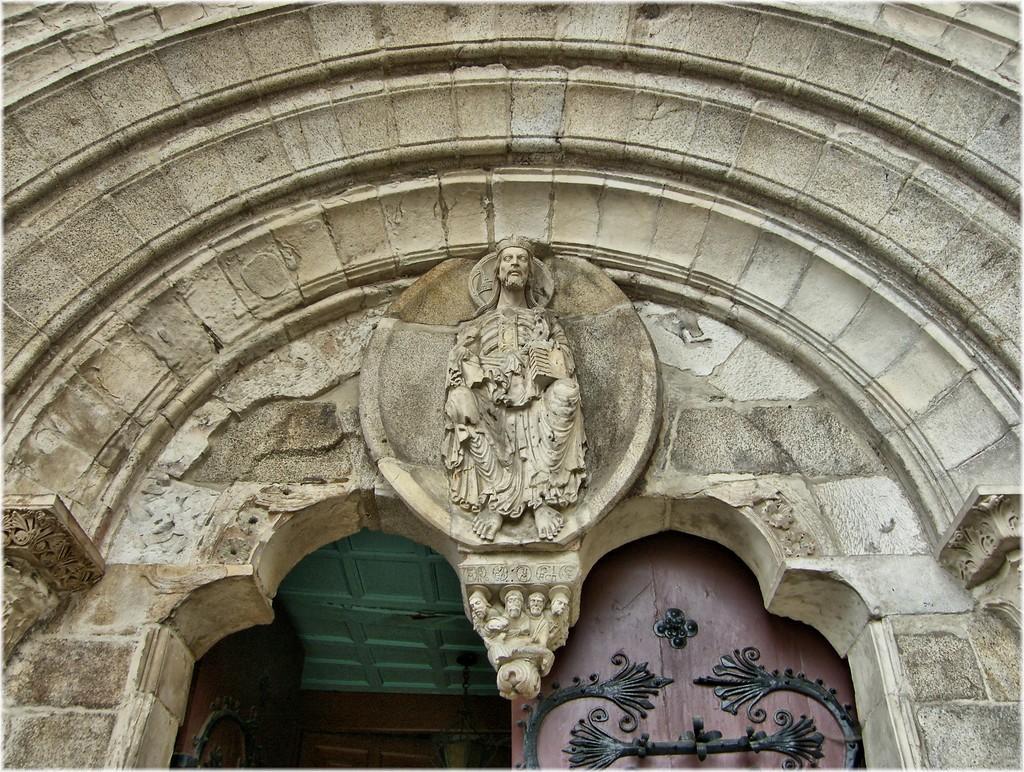Describe this image in one or two sentences. In this image we can see the top of the building. There is an architecture of a person on the wall of the building. There is an entrance door to the building. 